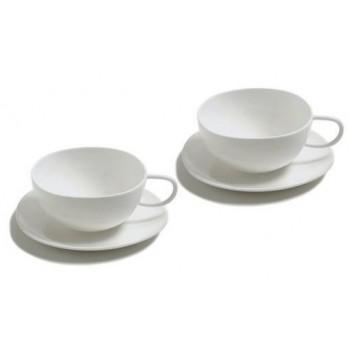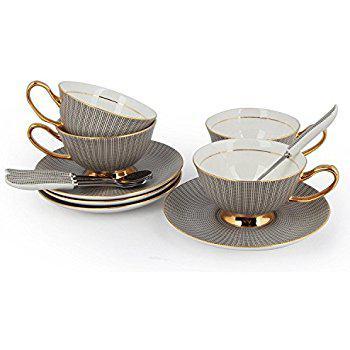The first image is the image on the left, the second image is the image on the right. Considering the images on both sides, is "An image shows beige dishware that look like melamine plastic." valid? Answer yes or no. No. 